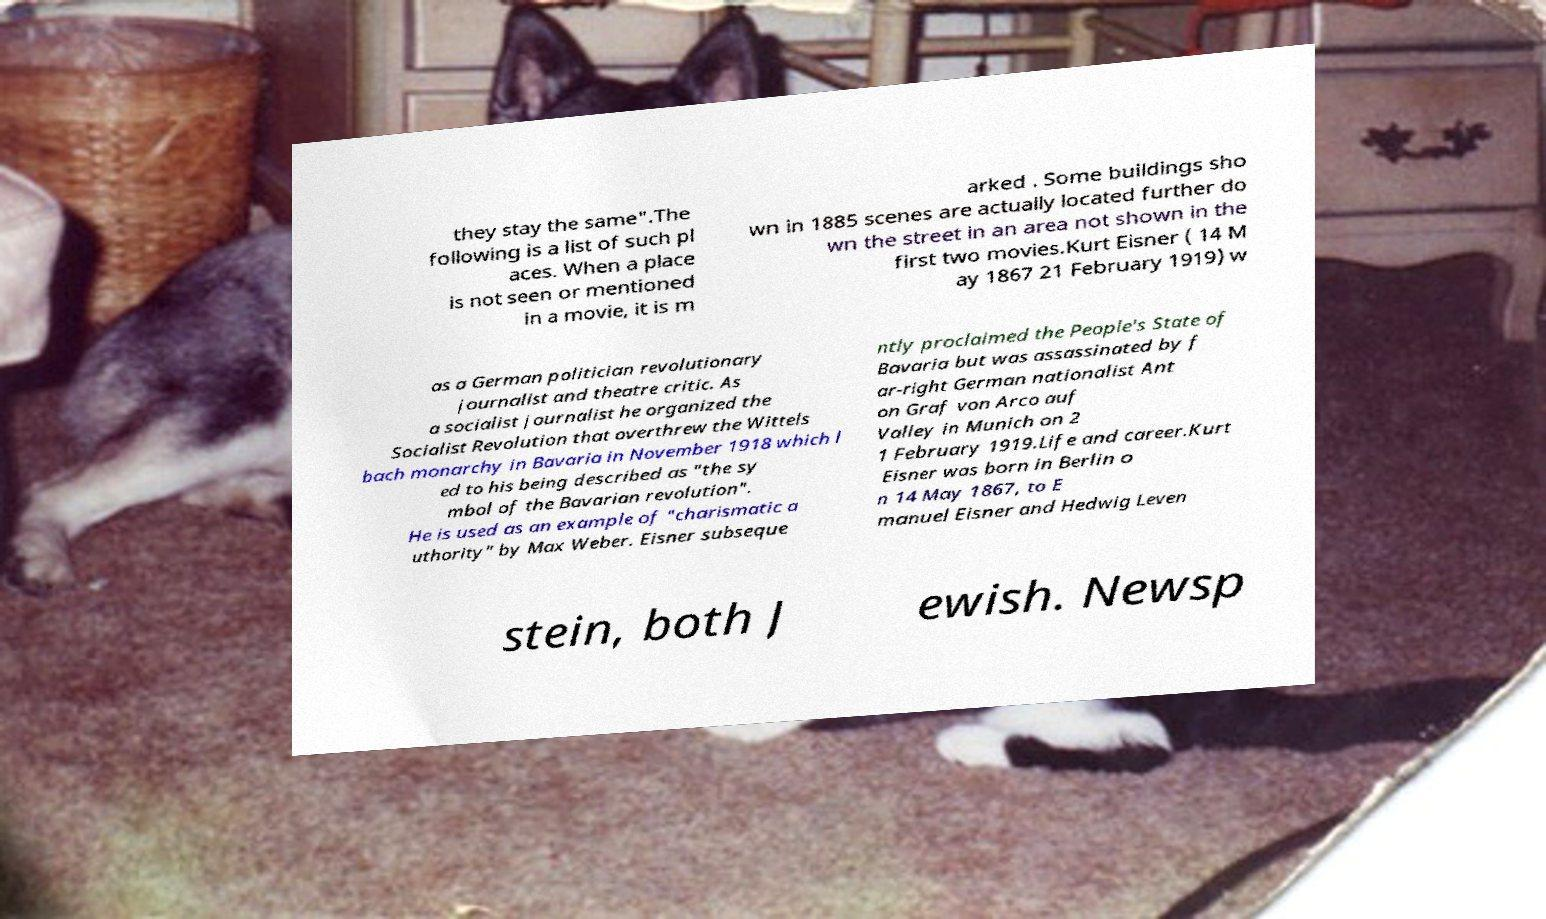Could you assist in decoding the text presented in this image and type it out clearly? they stay the same".The following is a list of such pl aces. When a place is not seen or mentioned in a movie, it is m arked . Some buildings sho wn in 1885 scenes are actually located further do wn the street in an area not shown in the first two movies.Kurt Eisner ( 14 M ay 1867 21 February 1919) w as a German politician revolutionary journalist and theatre critic. As a socialist journalist he organized the Socialist Revolution that overthrew the Wittels bach monarchy in Bavaria in November 1918 which l ed to his being described as "the sy mbol of the Bavarian revolution". He is used as an example of "charismatic a uthority" by Max Weber. Eisner subseque ntly proclaimed the People's State of Bavaria but was assassinated by f ar-right German nationalist Ant on Graf von Arco auf Valley in Munich on 2 1 February 1919.Life and career.Kurt Eisner was born in Berlin o n 14 May 1867, to E manuel Eisner and Hedwig Leven stein, both J ewish. Newsp 